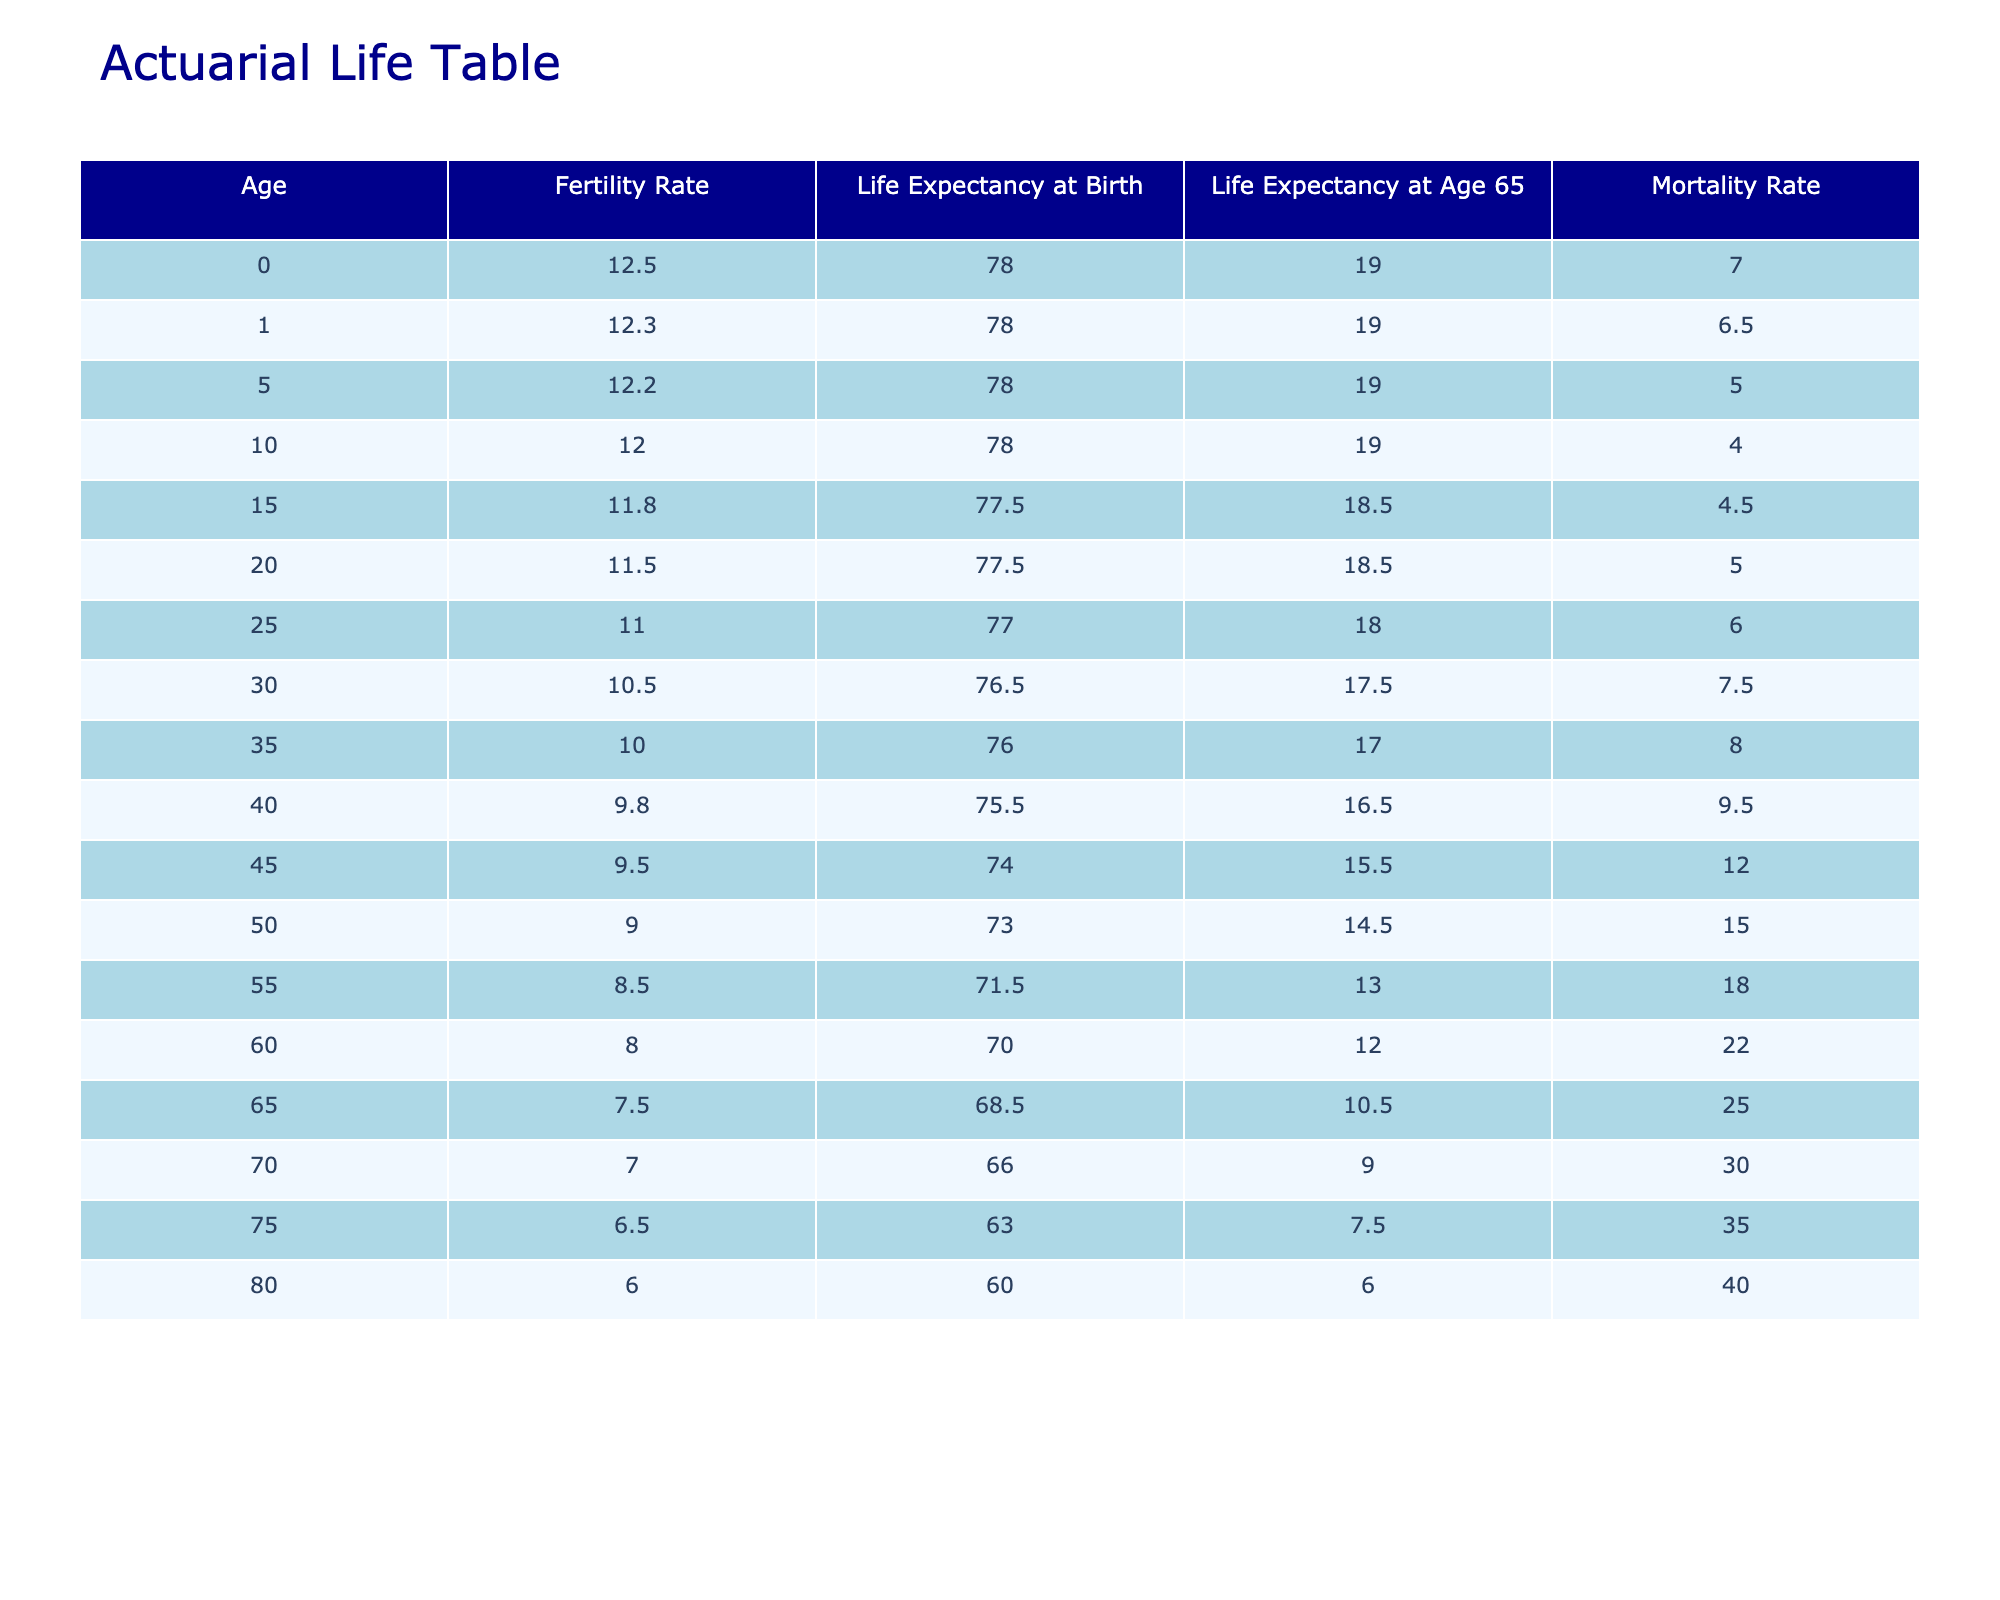What is the fertility rate for women aged 30? According to the table, the fertility rate for women aged 30 is listed as 10.5 births per 1000 women. This value can be directly retrieved from the corresponding cell in the "Fertility Rate" column for the age of 30.
Answer: 10.5 What is the life expectancy at birth for individuals aged 45? The table shows that the life expectancy at birth for individuals aged 45 is 74.0 years. This information is located in the "Life Expectancy at Birth" column for the age of 45.
Answer: 74.0 Is the mortality rate for individuals aged 70 higher than the mortality rate for those aged 75? The mortality rate for individuals aged 70 is 30.0 per 1000 people, while for those aged 75, it is 35.0 per 1000 people. Since 30.0 is less than 35.0, we can conclude that the mortality rate for individuals aged 70 is not higher than that for individuals aged 75.
Answer: No What is the difference in life expectancy at birth between the ages of 0 and 80? The life expectancy at birth for individuals aged 0 is 78.0 years, while for those aged 80, it is 60.0 years. To find the difference, we subtract 60.0 from 78.0, which gives us a difference of 18.0 years.
Answer: 18.0 What are the average fertility rates for women aged 0 through 20? The fertility rates for ages 0 to 20 are: 12.5, 12.3, 12.2, 12.0, 11.8, 11.5. To find the average, we sum these values (12.5 + 12.3 + 12.2 + 12.0 + 11.8 + 11.5 = 72.3) and divide by the number of values (6). Thus, the average is 72.3 / 6 = 12.05.
Answer: 12.05 Does the life expectancy at age 65 decrease as age increases? From the data in the table, life expectancy at age 65 shows the following values: at age 65 it is 10.5 years, at age 70 it is 9.0 years, and at age 75 it is 7.5 years. Thus, it can be observed that the life expectancy at age 65 does indeed decrease as one ages.
Answer: Yes What is the average life expectancy at age 65 for individuals aged 50 to 70? The life expectancy at age 65 for individuals aged 50 is 10.5 years, for age 55 it is 13.0 years, for age 60 it is 12.0 years, for age 65 it is also 10.5 years, for age 70 it is 9.0 years. We sum these values (10.5 + 13.0 + 12.0 + 10.5 + 9.0 = 55.0) and divide by the number of values (5), leading to an average of 11.0 years.
Answer: 11.0 